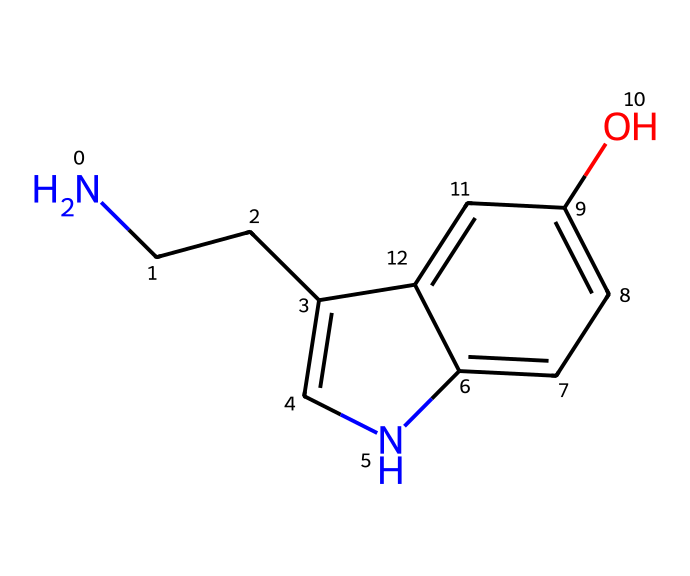How many carbon atoms are in the structure? By analyzing the provided SMILES representation, we can identify that there are 11 carbon (C) atoms present, which are indicated both explicitly by their symbols and by the structure as a whole.
Answer: 11 What functional groups are present in this molecule? Observing the structure, we can identify a hydroxyl group (-OH) from the presence of oxygen (O) bonded to a hydrogen and an amine group (-NH2) due to the nitrogen (N) atom. These groups contribute to the molecule’s behavior and properties.
Answer: hydroxyl and amine What is the molecular formula of serotonin based on the SMILES? To determine the molecular formula, we count the atoms from the SMILES: 11 carbon (C), 12 hydrogen (H), 1 nitrogen (N), and 1 oxygen (O), leading to the molecular formula C11H12N2O.
Answer: C11H12N2O How many rings are present in serotonin's structure? The structure can be analyzed by tracing the cycles; upon inspection, there are 2 cyclic systems highlighted by the connections between carbon atoms and nitrogen, making it a bicyclic compound.
Answer: 2 Does this molecule contain any double bonds? In the provided chemical structure, the presence of double bonds is inferred from the arrangement of the aromatic rings and functional groups. There is evidence of carbon-carbon double bonding as part of the aromatic nature of the structure.
Answer: yes What role does the nitrogen atom play in serotonin? The nitrogen atom contributes to the molecule's amine characteristics, which are responsible for interactions with neurotransmitter receptors in the brain. This is crucial for serotonin’s function as a mood regulator.
Answer: neurotransmitter interaction 